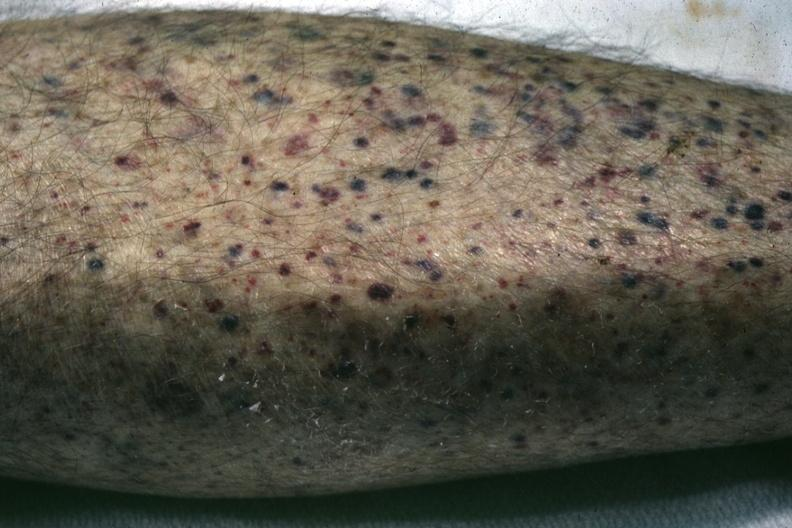s necrotic and ulcerated centers present?
Answer the question using a single word or phrase. No 